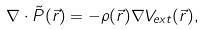Convert formula to latex. <formula><loc_0><loc_0><loc_500><loc_500>\nabla \cdot \tilde { P } ( \vec { r } ) = - \rho ( \vec { r } ) \nabla V _ { e x t } ( \vec { r } ) ,</formula> 